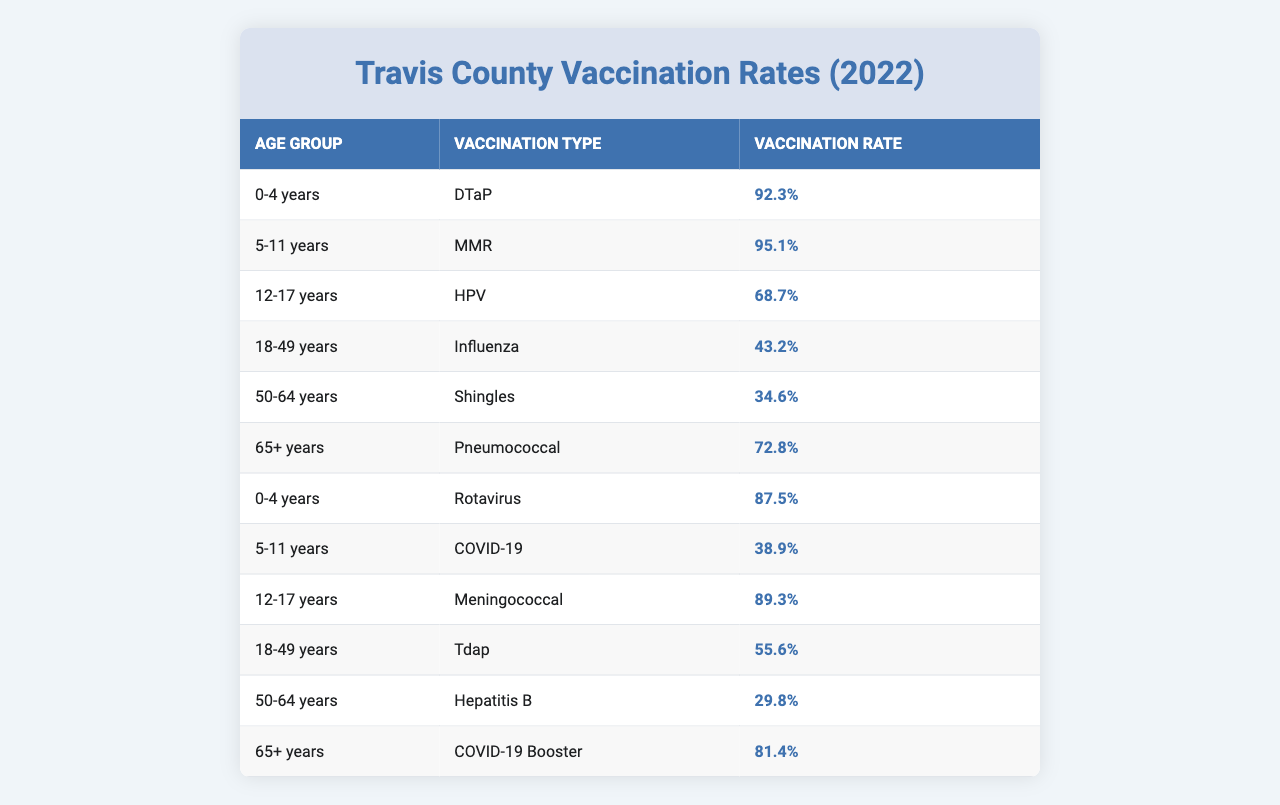What vaccination type has the highest rate for the age group 5-11 years? In the table, the vaccination type for the age group 5-11 years with the highest rate is MMR at 95.1%.
Answer: MMR What is the vaccination rate for COVID-19 in the 18-49 years age group? The table shows that the vaccination rate for COVID-19 in the 18-49 years age group is 43.2%.
Answer: 43.2% Which age group has the lowest vaccination rate for any vaccination type? The lowest vaccination rate in the table is for the 50-64 years age group with Hepatitis B at 29.8%.
Answer: 29.8% What is the average vaccination rate for all age groups concerning DTaP and Meningococcal? The rates for DTaP (92.3%) and Meningococcal (89.3%) are summed (92.3 + 89.3 = 181.6) and divided by 2 to get the average, which is 90.8%.
Answer: 90.8% Is the vaccination rate for the 65+ age group higher for Pneumococcal or COVID-19 Booster? The table shows that the vaccination rate for Pneumococcal is 72.8% and for COVID-19 Booster is 81.4%, indicating that the rate for COVID-19 Booster is higher.
Answer: Yes What is the difference in vaccination rates between the age groups 0-4 years for DTaP and Rotavirus? The DTaP rate is 92.3% and the Rotavirus rate is 87.5%. The difference is calculated by subtracting 87.5 from 92.3, which equals 4.8%.
Answer: 4.8% Which vaccination type has the highest rate for individuals aged 65 years and older? The table indicates that the highest vaccination rate for the 65+ age group is for the COVID-19 Booster at 81.4%.
Answer: COVID-19 Booster What is the total vaccination rate for children aged 0-4 years? The rates for DTaP (92.3%) and Rotavirus (87.5%) are added together (92.3 + 87.5 = 179.8%).
Answer: 179.8% How many vaccination types have a vaccination rate of over 80%? By examining the table, the vaccination types with rates over 80% are DTaP (92.3%), MMR (95.1%), Meningococcal (89.3%), and COVID-19 Booster (81.4%), making a total of 4 types.
Answer: 4 What percentage of individuals aged 12-17 years received HPV vaccine? According to the data in the table, the vaccination vaccination rate for HPV in the 12-17 years age group is 68.7%.
Answer: 68.7% If we look at the average vaccination rate of 18-49 years age group, how does it compare to the overall average? The rates for the 18-49 age group are 43.2% (Influenza) and 55.6% (Tdap), averaged as (43.2 + 55.6) / 2 = 49.4%. The overall average across all types would be calculated separately, indicating the comparison needs the overall average for full context.
Answer: 49.4% 